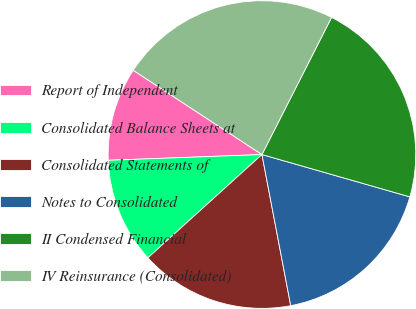<chart> <loc_0><loc_0><loc_500><loc_500><pie_chart><fcel>Report of Independent<fcel>Consolidated Balance Sheets at<fcel>Consolidated Statements of<fcel>Notes to Consolidated<fcel>II Condensed Financial<fcel>IV Reinsurance (Consolidated)<nl><fcel>9.82%<fcel>11.12%<fcel>16.28%<fcel>17.57%<fcel>21.96%<fcel>23.25%<nl></chart> 